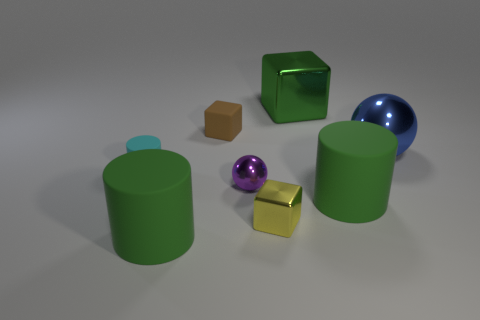How many objects are there in total, and can you describe their shapes and materials? There are six objects in total. Starting from the left, there’s a green cylinder with a blue cap, a green cube, a small brown cube, a small purple sphere, a yellow metallic cube, and on the far right, a large blue sphere. 